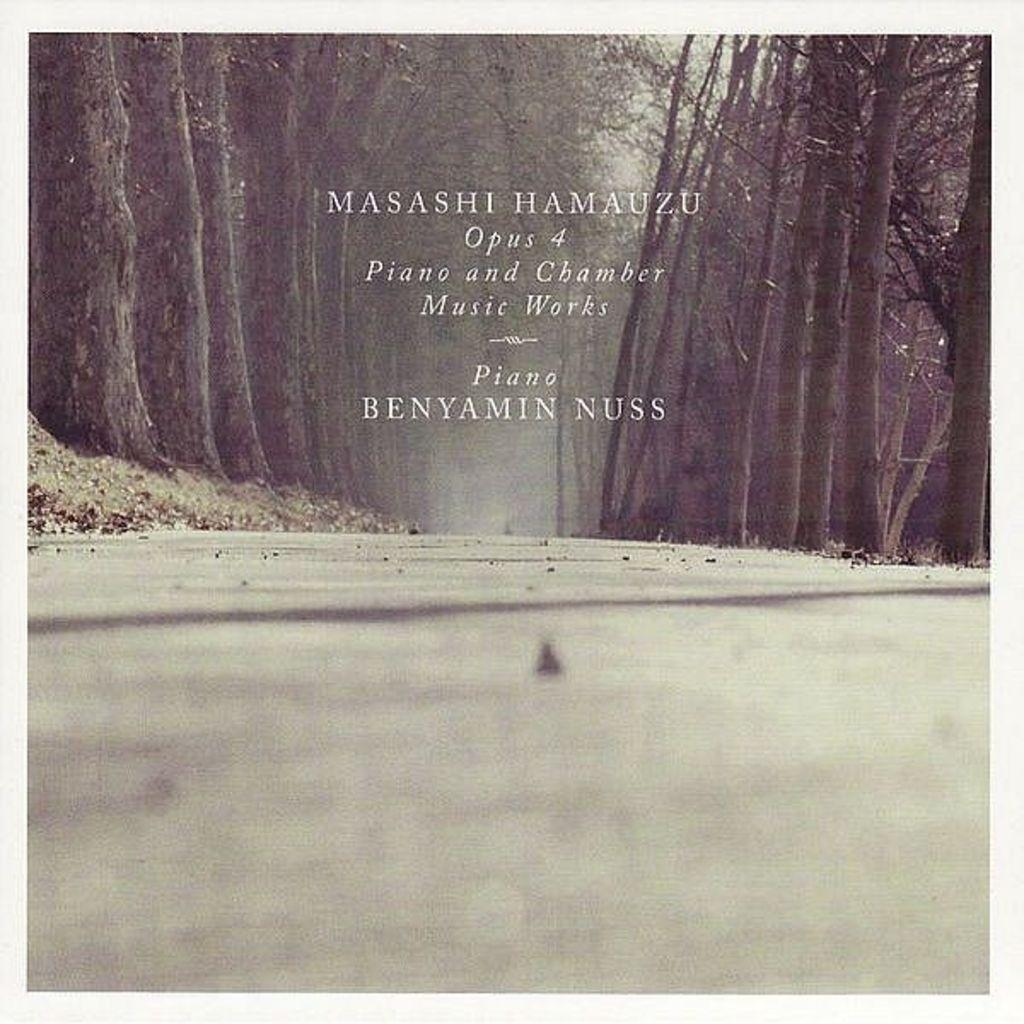What is the main focus of the image? The center of the image contains the sky, trees, dry leaves, a road, and a few other objects. Can you describe the sky in the image? The sky is visible in the center of the image. What type of vegetation can be seen in the image? Trees are present in the center of the image. What might be found on the ground in the image? Dry leaves are visible in the center of the image. What type of pathway is present in the image? There is a road in the center of the image. Are there any words or letters in the image? Yes, there is some text in the middle of the image. How does the disgust affect the whip in the image? There is no whip or any indication of disgust present in the image. 